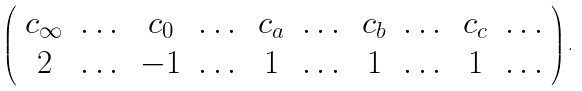Convert formula to latex. <formula><loc_0><loc_0><loc_500><loc_500>\left ( \begin{array} { c c c c c c c c c c } c _ { \infty } & \dots & c _ { 0 } & \dots & c _ { a } & \dots & c _ { b } & \dots & c _ { c } & \dots \\ 2 & \dots & - 1 & \dots & 1 & \dots & 1 & \dots & 1 & \dots \end{array} \right ) .</formula> 